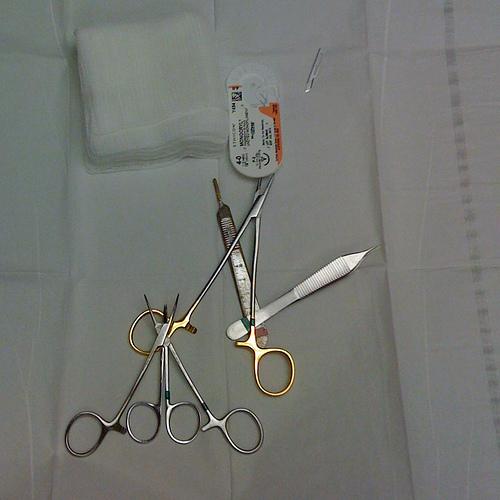What are the color of the handles on the scissors?
Short answer required. Silver. How many scissors are there?
Short answer required. 3. Are these hospital tools?
Keep it brief. Yes. What color is the hand of the scissors?
Quick response, please. Gold. The scissors gold?
Quick response, please. Yes. Which scissors are largest?
Write a very short answer. Gold handled. How many pairs of scissors in this photo?
Give a very brief answer. 3. Is this object for sale?
Quick response, please. No. Are the instruments sterile?
Quick response, please. No. What is the table made of?
Answer briefly. Wood. Is it really necessary to have so many types and sizes of scissors?
Quick response, please. No. Are there forceps here?
Concise answer only. Yes. What object are the scissors pointed toward?
Keep it brief. Gauze. What are these instruments for?
Quick response, please. Cutting. What kind of tool is in the middle?
Quick response, please. Scissors. 